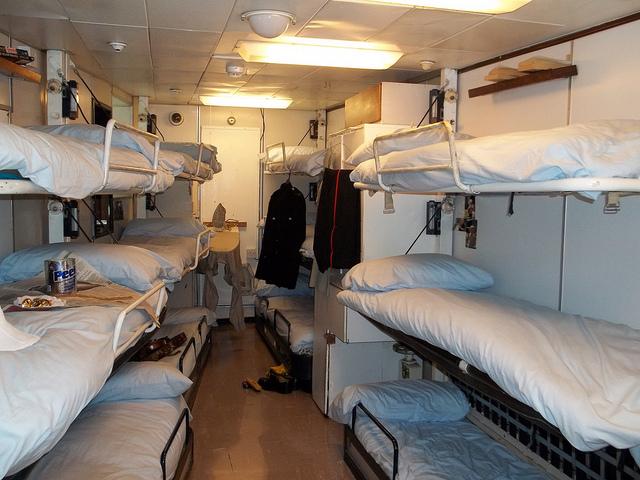Are the lights on?
Be succinct. Yes. Is this room in a dormitory?
Quick response, please. Yes. What room is this?
Concise answer only. Bedroom. 